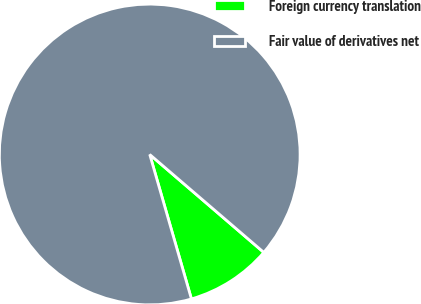<chart> <loc_0><loc_0><loc_500><loc_500><pie_chart><fcel>Foreign currency translation<fcel>Fair value of derivatives net<nl><fcel>9.24%<fcel>90.76%<nl></chart> 